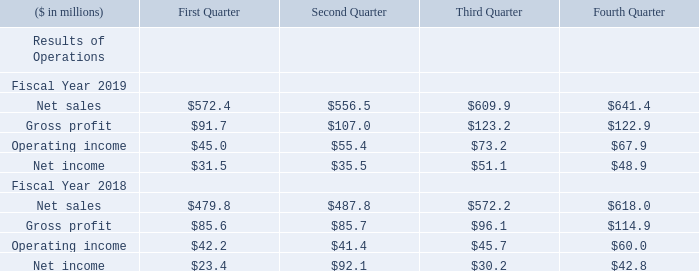Quarterly Financial Data (Unaudited)
Quarterly sales and earnings results are normally influenced by seasonal factors. Historically, the first two fiscal quarters (three months ending September 30 and December 31) are typically the lowest principally because of annual plant vacation and maintenance shutdowns by the Company and by many of its customers. However, the timing of major changes in the general economy or the markets for certain products can alter this pattern.
During the quarter ended December 31, 2017, the Company recorded an income tax benefit. See Note 17, Income Taxes to Notes to Consolidated Financial Statements included in Item 8. “Financial Statements and Supplementary Data”.
What are Quarterly sales and earnings results normally influenced by? Seasonal factors. Why are the first two fiscal quarters typically the lowest? Principally because of annual plant vacation and maintenance shutdowns by the company and by many of its customers. however, the timing of major changes in the general economy or the markets for certain products can alter this pattern. What is the net sales for 2019 for each quarter in chronological order?
Answer scale should be: million. $572.4, $556.5, $609.9, $641.4. Which quarter was the net income in 2019 the largest? 51.1>48.9>35.5>31.5
Answer: third quarter. What was the change in net income in First Quarter in 2019 from 2018?
Answer scale should be: million. 31.5-23.4
Answer: 8.1. What was the percentage change in net income in First Quarter in 2019 from 2018?
Answer scale should be: percent. (31.5-23.4)/23.4
Answer: 34.62. 